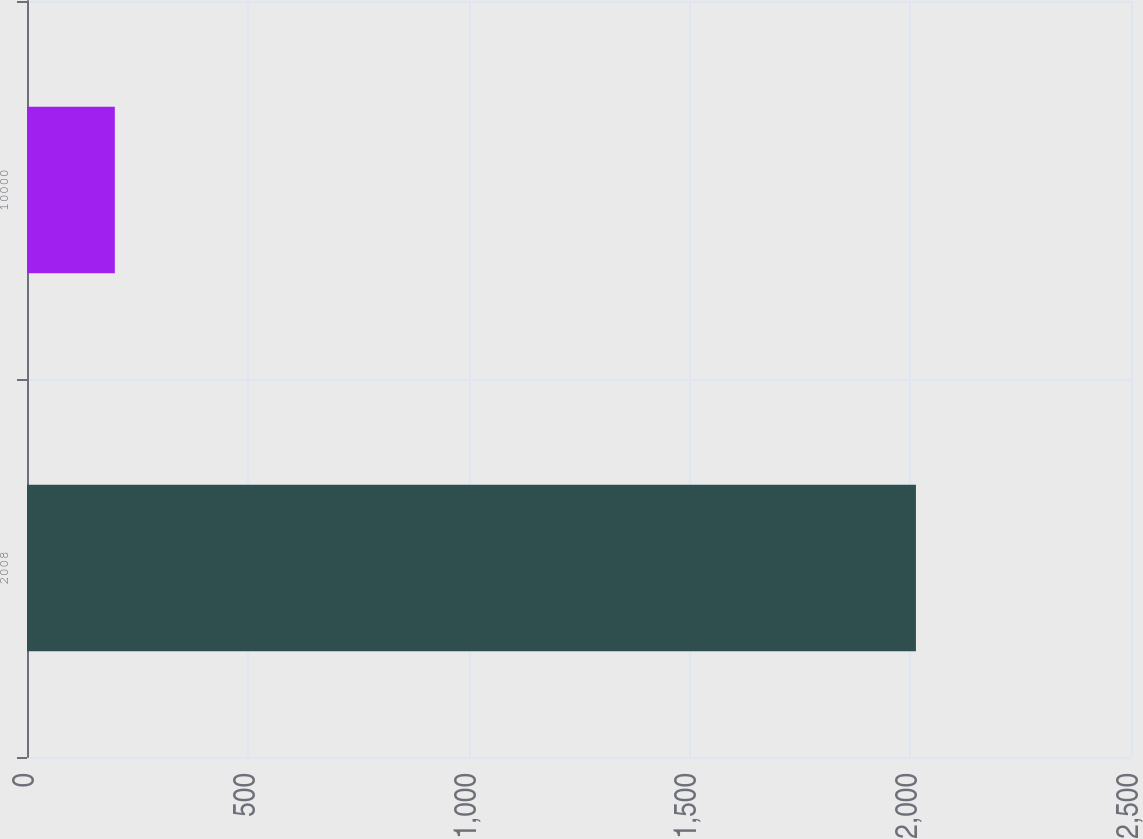<chart> <loc_0><loc_0><loc_500><loc_500><bar_chart><fcel>2008<fcel>10000<nl><fcel>2013<fcel>198.87<nl></chart> 